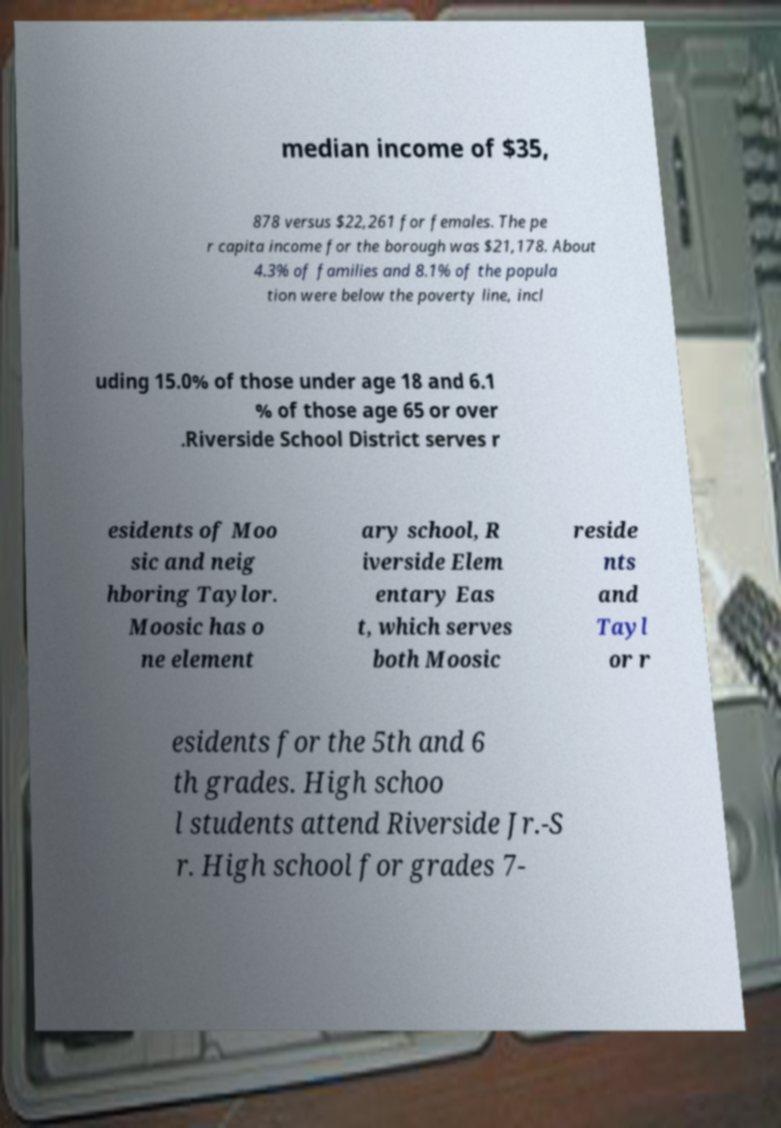Could you assist in decoding the text presented in this image and type it out clearly? median income of $35, 878 versus $22,261 for females. The pe r capita income for the borough was $21,178. About 4.3% of families and 8.1% of the popula tion were below the poverty line, incl uding 15.0% of those under age 18 and 6.1 % of those age 65 or over .Riverside School District serves r esidents of Moo sic and neig hboring Taylor. Moosic has o ne element ary school, R iverside Elem entary Eas t, which serves both Moosic reside nts and Tayl or r esidents for the 5th and 6 th grades. High schoo l students attend Riverside Jr.-S r. High school for grades 7- 